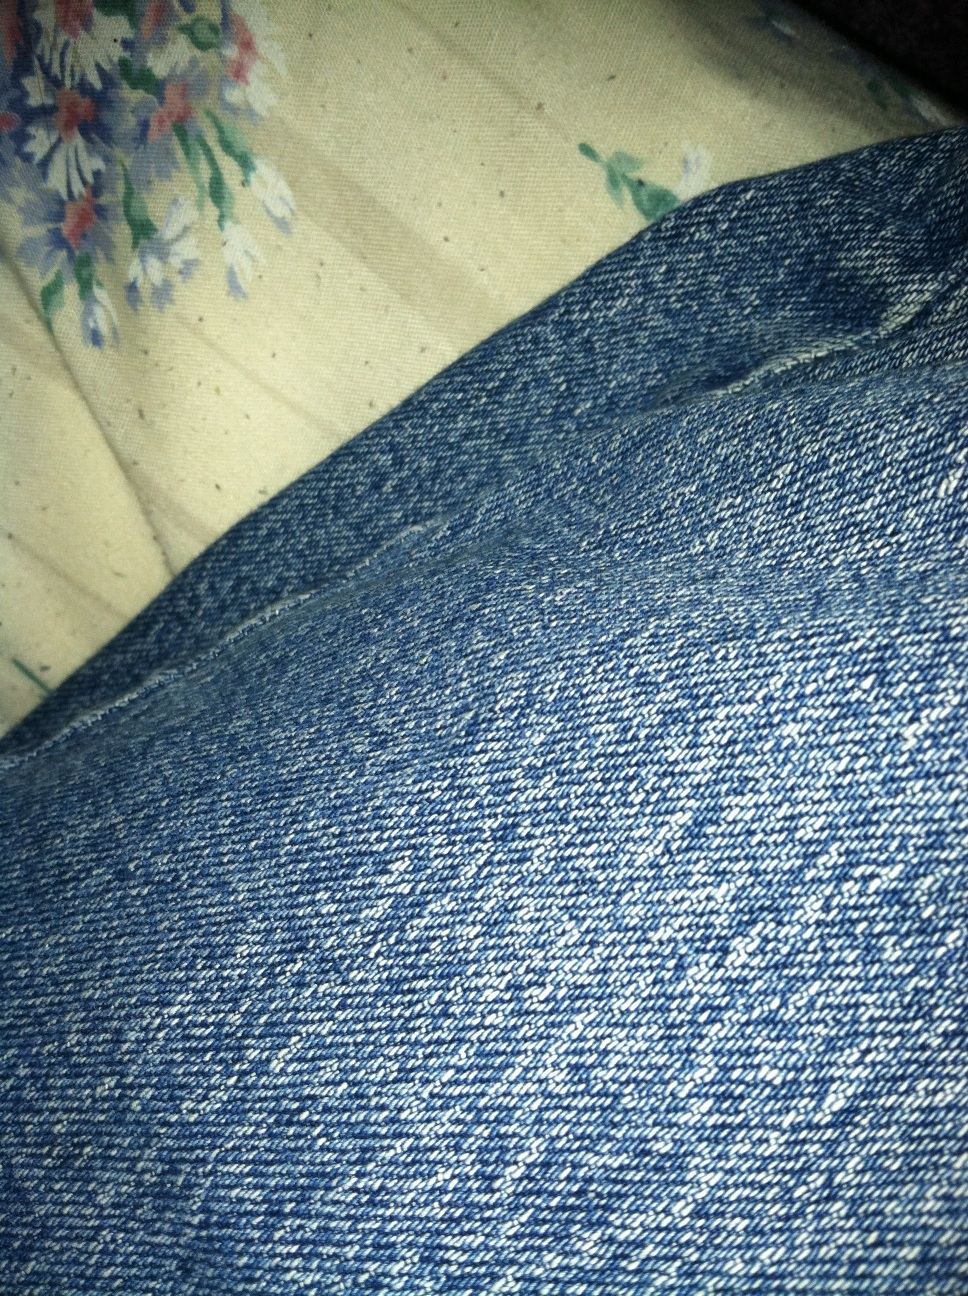If these jeans had a history rooted in a fantastical world, what would it be like? In a fantastical world, these jeans might have been woven from the magical threads of a rare, enchanted cotton plant found only in hidden groves protected by guardian spirits. The fabric would shimmer faintly with a mystical aura, granting the wearer slight enhancements in strength and agility. Crafted by the skilled hands of ancient artisans who've mastered the art of mystical weaving, these jeans would bear intricate patterns that tell stories of legendary heroes and mythical creatures. As the wearer embarks on daring quests, the jeans might react to their bravery, glowing warmly in moments of valor and courage, and even repairing themselves if damaged during adventures. In a realistic scenario, where might these jeans be most suitable to wear? These blue jeans would be most suitable for a wide range of everyday situations. Perfect for a casual day out shopping or meeting friends, they offer comfort and durability. They’re also great for casual Fridays at the office, paired with a blazer or a neat shirt, effortlessly blending comfort with a touch of style. Whether you're running errands, going for a casual lunch, or exploring the city, these jeans are a reliable choice that can be dressed up or down depending on the occasion. What might be the sentiment of someone wearing these jeans on a relaxed Sunday? On a relaxed Sunday, someone wearing these jeans might feel at ease and content. The familiar, worn-in comfort of their favorite jeans could make them feel cozy and laid-back, ready to enjoy a leisurely day. Whether they’re lounging at home, enjoying a stroll in the park, or catching up with friends over a cup of coffee, the jeans would symbolize casual comfort and versatility, contributing to a sense of ease and relaxation throughout their day. 